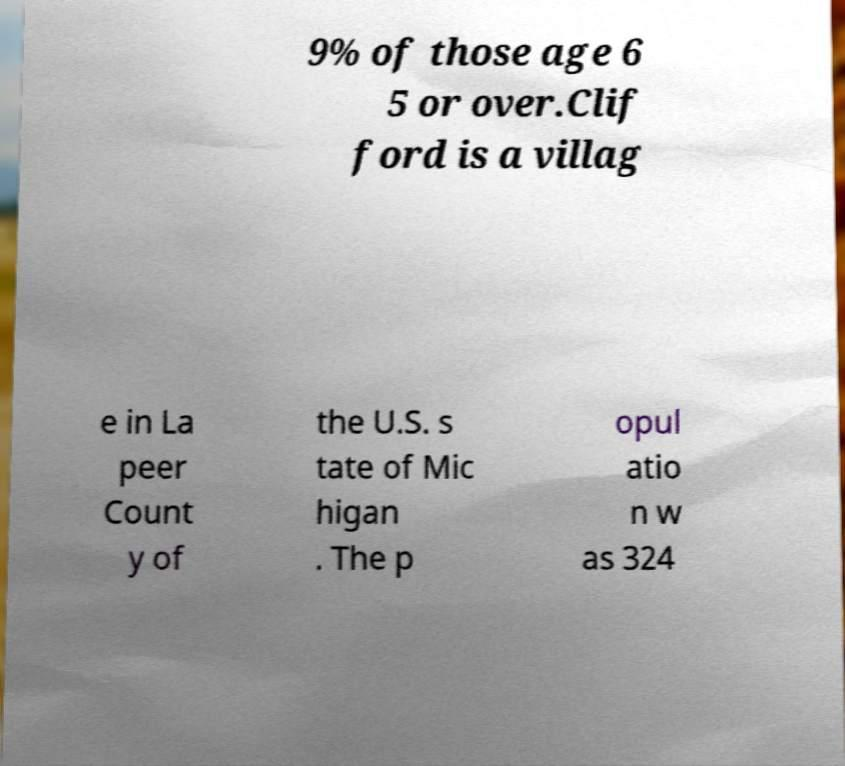There's text embedded in this image that I need extracted. Can you transcribe it verbatim? 9% of those age 6 5 or over.Clif ford is a villag e in La peer Count y of the U.S. s tate of Mic higan . The p opul atio n w as 324 